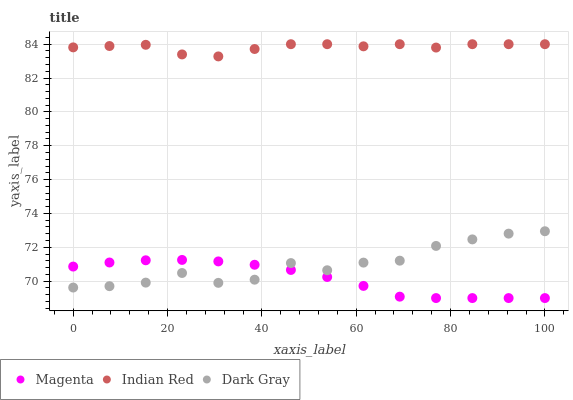Does Magenta have the minimum area under the curve?
Answer yes or no. Yes. Does Indian Red have the maximum area under the curve?
Answer yes or no. Yes. Does Indian Red have the minimum area under the curve?
Answer yes or no. No. Does Magenta have the maximum area under the curve?
Answer yes or no. No. Is Magenta the smoothest?
Answer yes or no. Yes. Is Dark Gray the roughest?
Answer yes or no. Yes. Is Indian Red the smoothest?
Answer yes or no. No. Is Indian Red the roughest?
Answer yes or no. No. Does Magenta have the lowest value?
Answer yes or no. Yes. Does Indian Red have the lowest value?
Answer yes or no. No. Does Indian Red have the highest value?
Answer yes or no. Yes. Does Magenta have the highest value?
Answer yes or no. No. Is Dark Gray less than Indian Red?
Answer yes or no. Yes. Is Indian Red greater than Magenta?
Answer yes or no. Yes. Does Magenta intersect Dark Gray?
Answer yes or no. Yes. Is Magenta less than Dark Gray?
Answer yes or no. No. Is Magenta greater than Dark Gray?
Answer yes or no. No. Does Dark Gray intersect Indian Red?
Answer yes or no. No. 